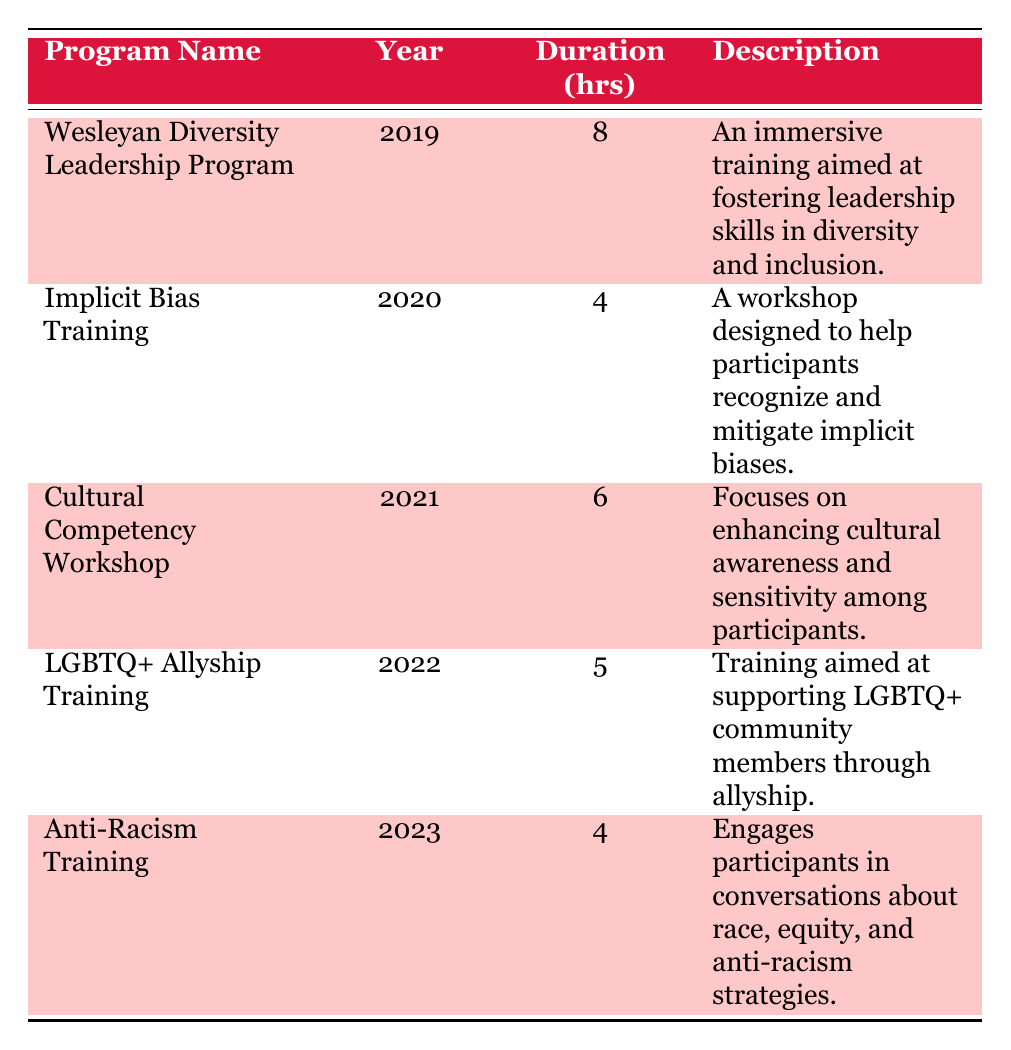What was the program with the most participants in 2023? In 2023, the program listed is Anti-Racism Training with 120 participants, making it the program with the highest attendance for that year.
Answer: Anti-Racism Training How many hours of training were offered in the Wesleyan Diversity Leadership Program? The Wesleyan Diversity Leadership Program, conducted in 2019, lasted for 8 hours as stated in the table.
Answer: 8 hours Which program focused on LGBTQ+ issues? The program focused on LGBTQ+ issues is the LGBTQ+ Allyship Training, offered in 2022 as indicated in the table.
Answer: LGBTQ+ Allyship Training What is the total number of participants in all diversity and inclusion training programs over the five years? To find the total, we sum the participants from each year: 75 + 60 + 85 + 100 + 120 = 440. Therefore, the total number of participants is 440.
Answer: 440 Did the number of participants in diversity and inclusion training programs increase from 2019 to 2023? Yes, the number of participants increased from 75 in 2019 to 120 in 2023, indicating a growth over the years.
Answer: Yes Which program had the shortest duration based on the table? The program with the shortest duration is Implicit Bias Training, which lasted for 4 hours, based on the information presented in the table.
Answer: 4 hours What is the average number of participants over the five years? To calculate the average, sum the participants and divide by the number of programs: (75 + 60 + 85 + 100 + 120) / 5 = 88. Therefore, the average number of participants is 88.
Answer: 88 Was there a program that occurred in every year from 2019 to 2023? No, each program listed in the table corresponds to a different year, meaning there were no repeating programs during this time span.
Answer: No In which year did the Cultural Competency Workshop take place? The Cultural Competency Workshop took place in 2021, as described in the data provided in the table.
Answer: 2021 